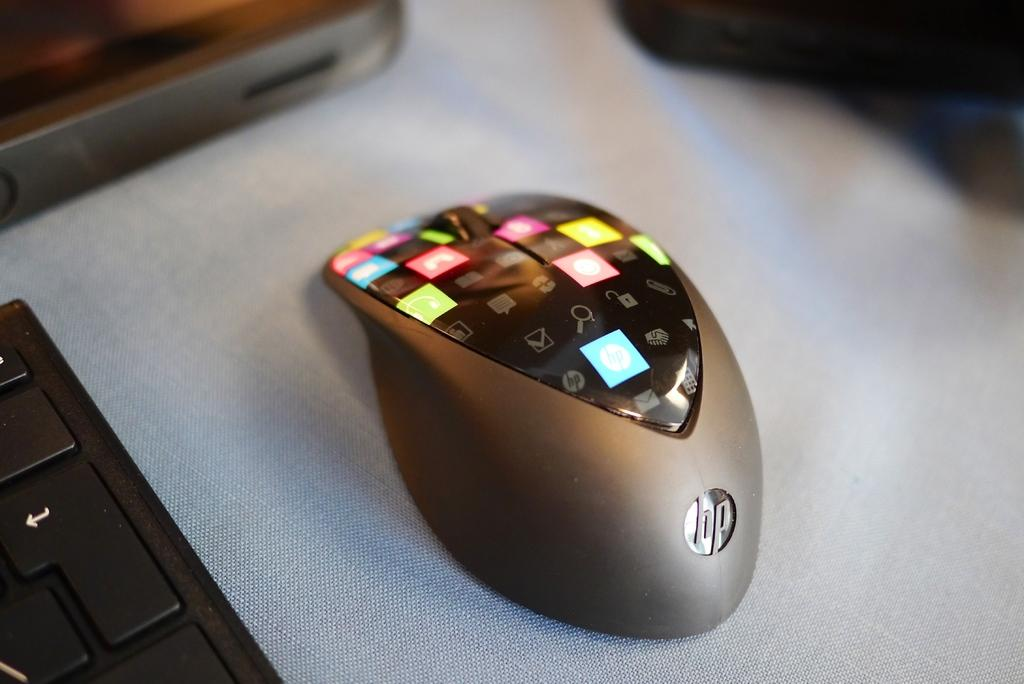<image>
Share a concise interpretation of the image provided. A superfancy wireless HP mouse with many different buttons. 